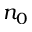Convert formula to latex. <formula><loc_0><loc_0><loc_500><loc_500>n _ { 0 }</formula> 